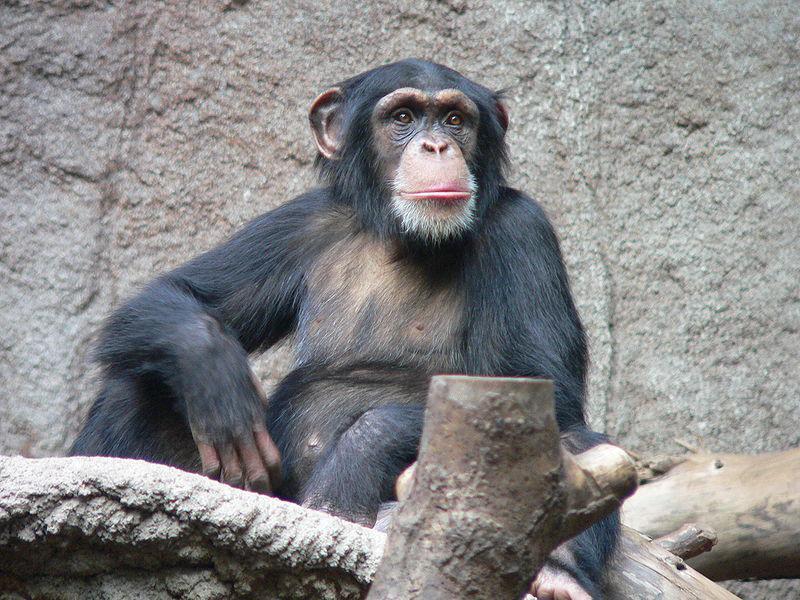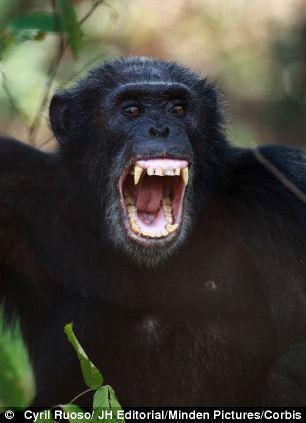The first image is the image on the left, the second image is the image on the right. Given the left and right images, does the statement "There is at most 1 black monkey with its mouth open." hold true? Answer yes or no. Yes. The first image is the image on the left, the second image is the image on the right. Given the left and right images, does the statement "one chimp has its mouth open wide" hold true? Answer yes or no. Yes. 